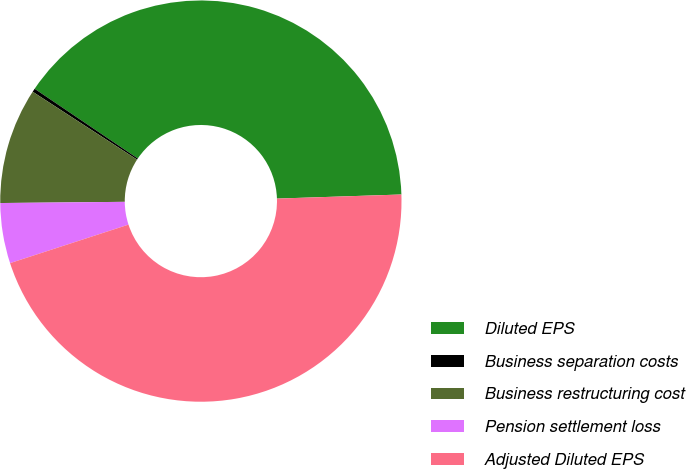Convert chart to OTSL. <chart><loc_0><loc_0><loc_500><loc_500><pie_chart><fcel>Diluted EPS<fcel>Business separation costs<fcel>Business restructuring cost<fcel>Pension settlement loss<fcel>Adjusted Diluted EPS<nl><fcel>40.02%<fcel>0.28%<fcel>9.33%<fcel>4.85%<fcel>45.52%<nl></chart> 